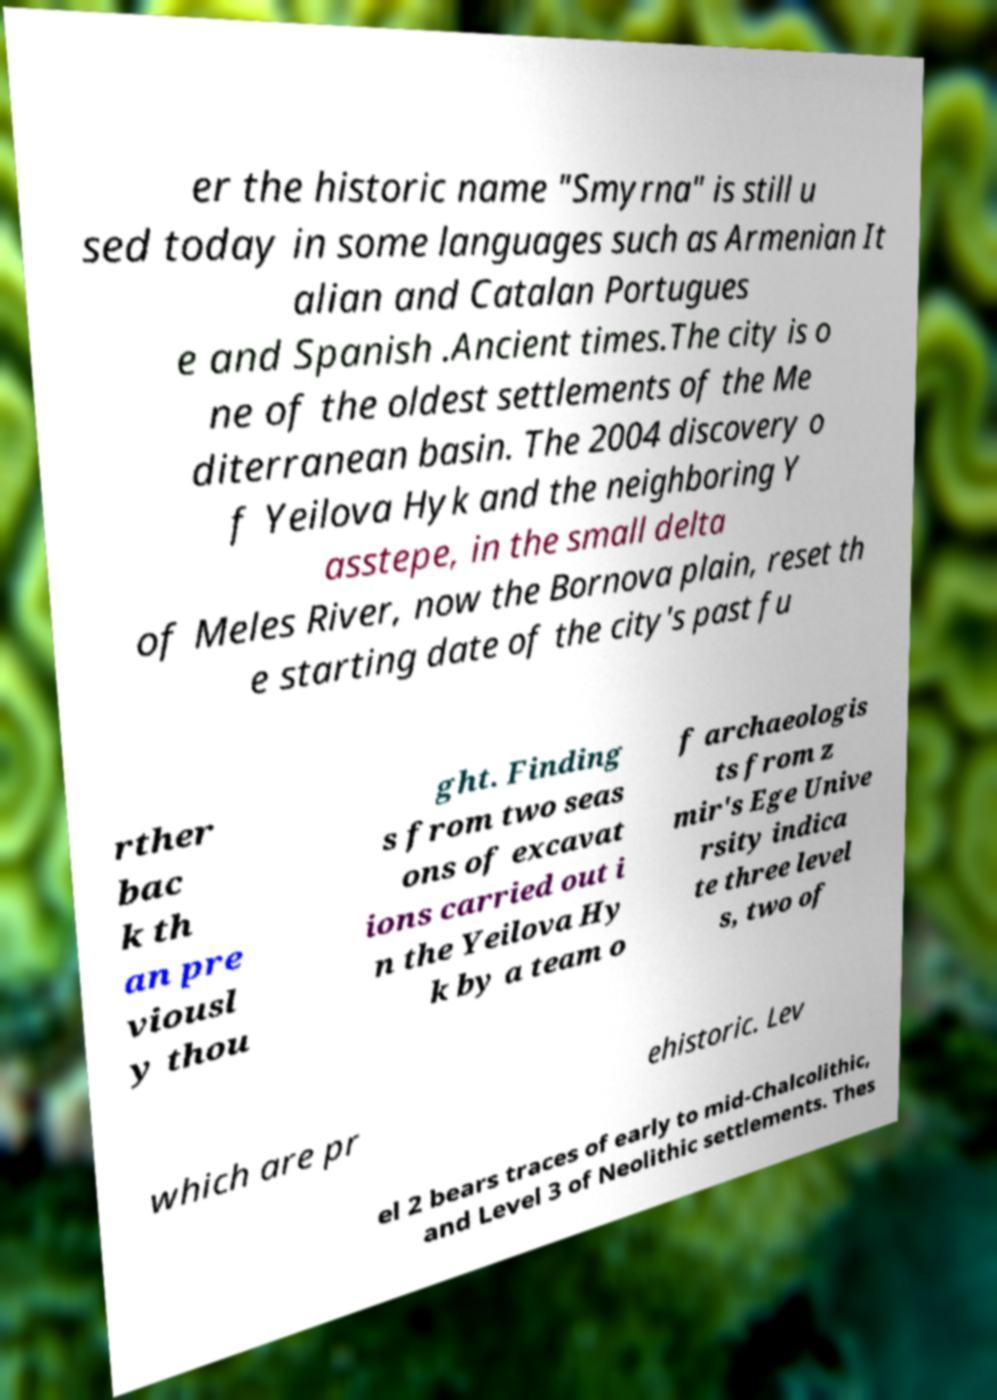Can you read and provide the text displayed in the image?This photo seems to have some interesting text. Can you extract and type it out for me? er the historic name "Smyrna" is still u sed today in some languages such as Armenian It alian and Catalan Portugues e and Spanish .Ancient times.The city is o ne of the oldest settlements of the Me diterranean basin. The 2004 discovery o f Yeilova Hyk and the neighboring Y asstepe, in the small delta of Meles River, now the Bornova plain, reset th e starting date of the city's past fu rther bac k th an pre viousl y thou ght. Finding s from two seas ons of excavat ions carried out i n the Yeilova Hy k by a team o f archaeologis ts from z mir's Ege Unive rsity indica te three level s, two of which are pr ehistoric. Lev el 2 bears traces of early to mid-Chalcolithic, and Level 3 of Neolithic settlements. Thes 